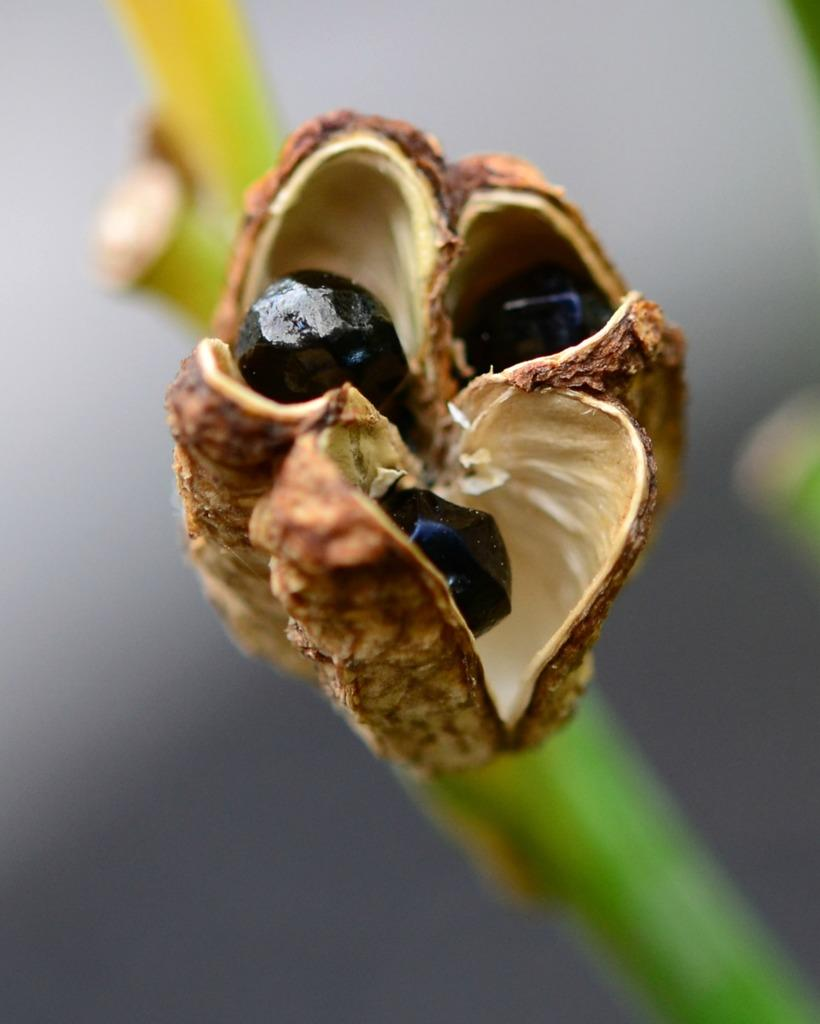What is the main subject of the image? There is a flower in the center of the image. Can you describe the flower in more detail? Unfortunately, the image only shows the flower in the center, and no additional details are provided. What might be the purpose of the image? The purpose of the image could be to showcase the beauty or uniqueness of the flower. How many steps are required to reach the hot sheet in the image? There is no mention of steps, heat, or sheets in the image; it only features a flower. 